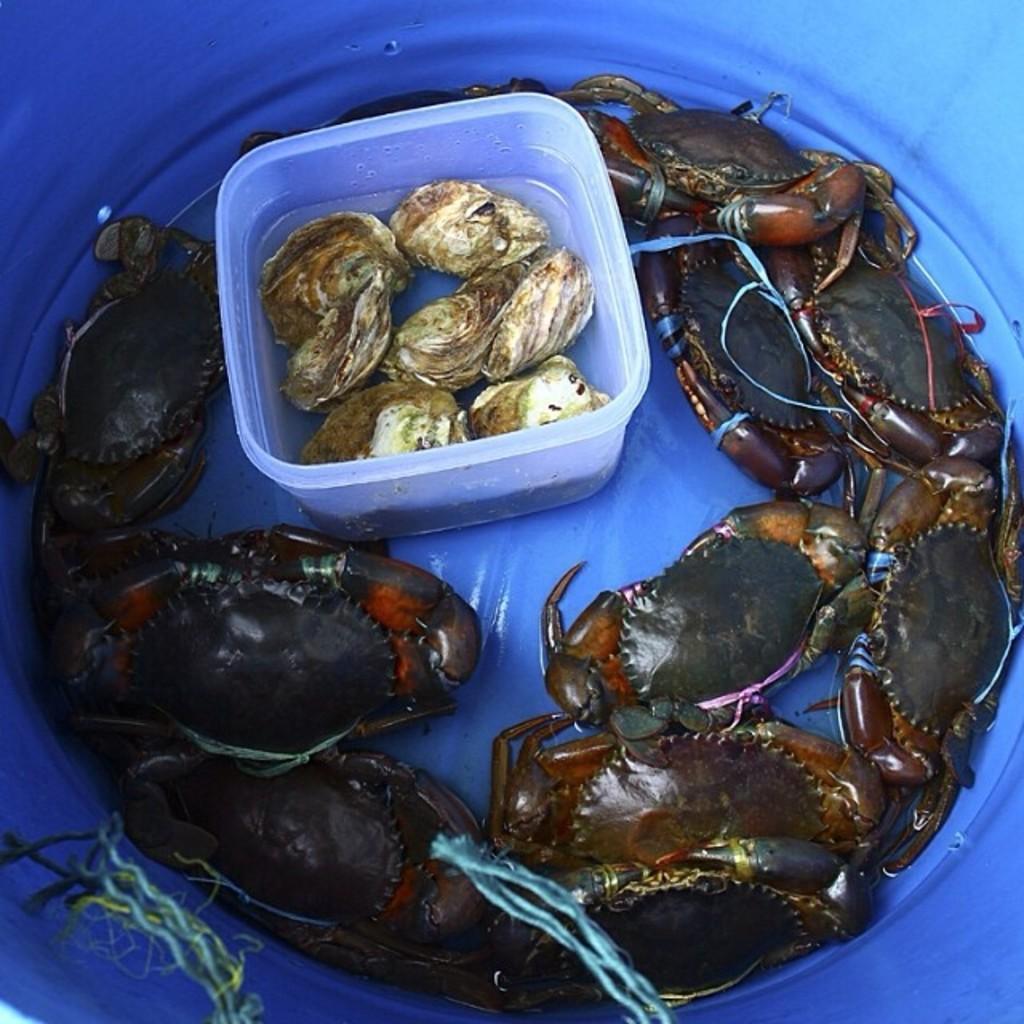Can you describe this image briefly? In this picture there are crabs in the tub and there are ferrets in the box,there is water in it. 